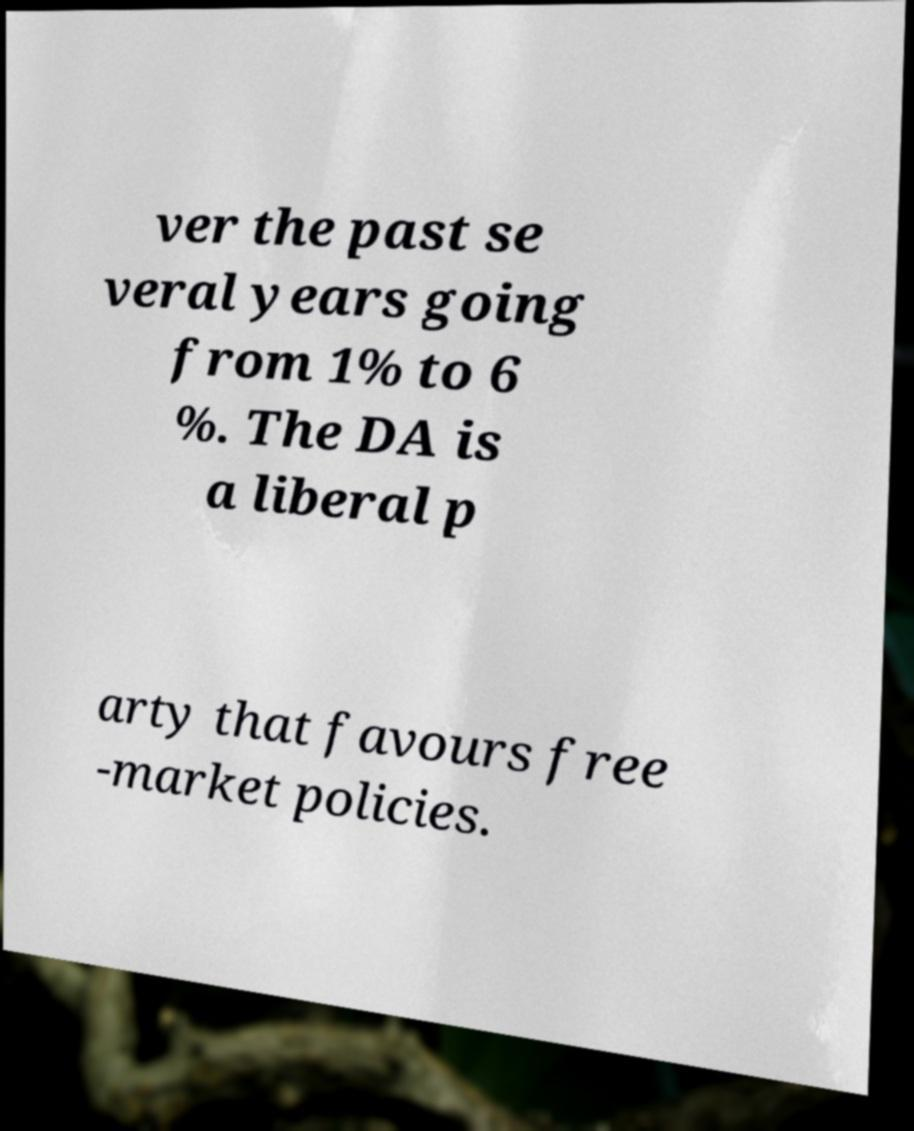Can you accurately transcribe the text from the provided image for me? ver the past se veral years going from 1% to 6 %. The DA is a liberal p arty that favours free -market policies. 